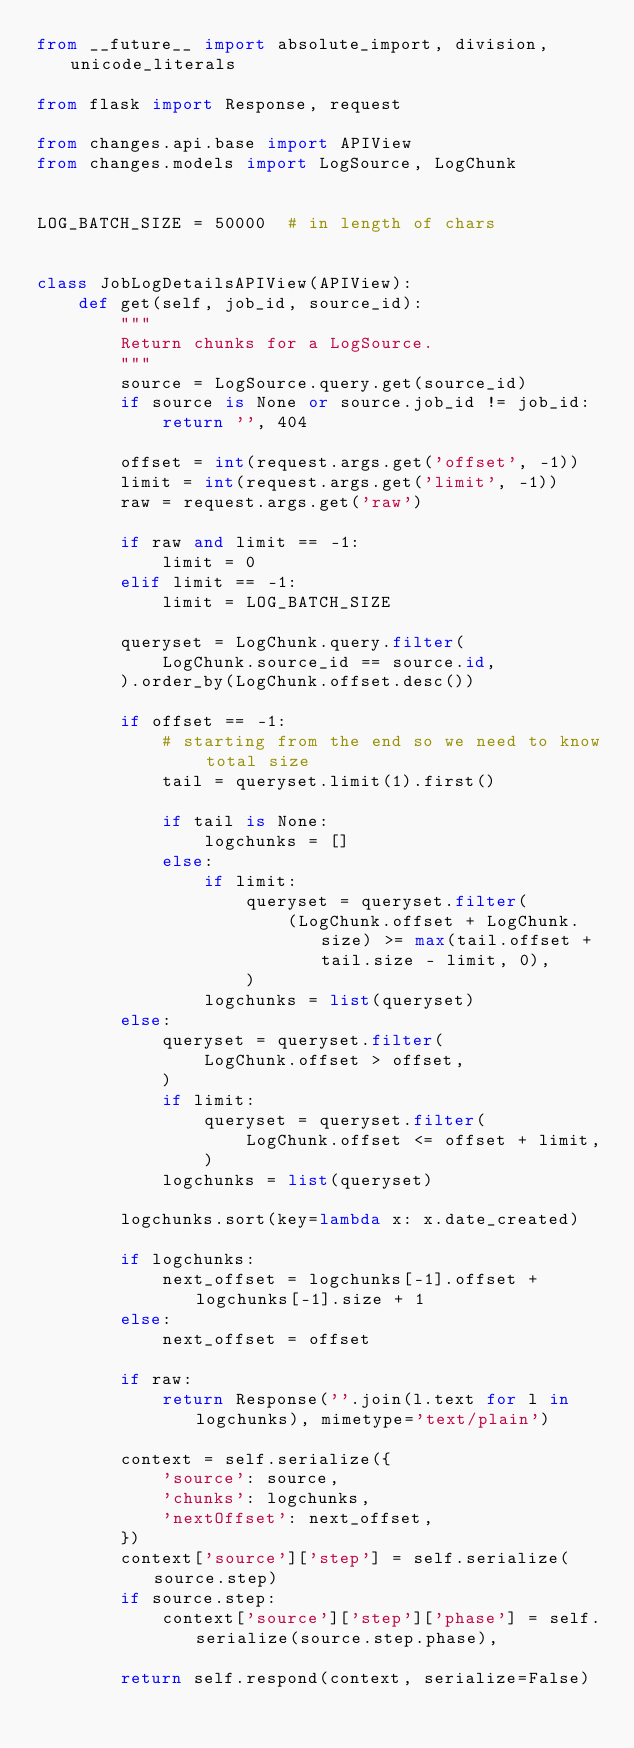Convert code to text. <code><loc_0><loc_0><loc_500><loc_500><_Python_>from __future__ import absolute_import, division, unicode_literals

from flask import Response, request

from changes.api.base import APIView
from changes.models import LogSource, LogChunk


LOG_BATCH_SIZE = 50000  # in length of chars


class JobLogDetailsAPIView(APIView):
    def get(self, job_id, source_id):
        """
        Return chunks for a LogSource.
        """
        source = LogSource.query.get(source_id)
        if source is None or source.job_id != job_id:
            return '', 404

        offset = int(request.args.get('offset', -1))
        limit = int(request.args.get('limit', -1))
        raw = request.args.get('raw')

        if raw and limit == -1:
            limit = 0
        elif limit == -1:
            limit = LOG_BATCH_SIZE

        queryset = LogChunk.query.filter(
            LogChunk.source_id == source.id,
        ).order_by(LogChunk.offset.desc())

        if offset == -1:
            # starting from the end so we need to know total size
            tail = queryset.limit(1).first()

            if tail is None:
                logchunks = []
            else:
                if limit:
                    queryset = queryset.filter(
                        (LogChunk.offset + LogChunk.size) >= max(tail.offset + tail.size - limit, 0),
                    )
                logchunks = list(queryset)
        else:
            queryset = queryset.filter(
                LogChunk.offset > offset,
            )
            if limit:
                queryset = queryset.filter(
                    LogChunk.offset <= offset + limit,
                )
            logchunks = list(queryset)

        logchunks.sort(key=lambda x: x.date_created)

        if logchunks:
            next_offset = logchunks[-1].offset + logchunks[-1].size + 1
        else:
            next_offset = offset

        if raw:
            return Response(''.join(l.text for l in logchunks), mimetype='text/plain')

        context = self.serialize({
            'source': source,
            'chunks': logchunks,
            'nextOffset': next_offset,
        })
        context['source']['step'] = self.serialize(source.step)
        if source.step:
            context['source']['step']['phase'] = self.serialize(source.step.phase),

        return self.respond(context, serialize=False)
</code> 